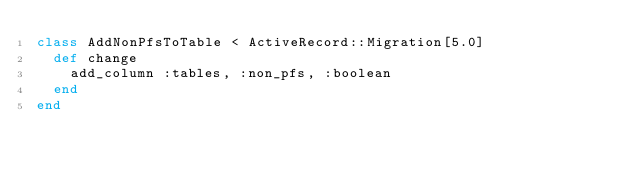Convert code to text. <code><loc_0><loc_0><loc_500><loc_500><_Ruby_>class AddNonPfsToTable < ActiveRecord::Migration[5.0]
  def change
    add_column :tables, :non_pfs, :boolean
  end
end
</code> 